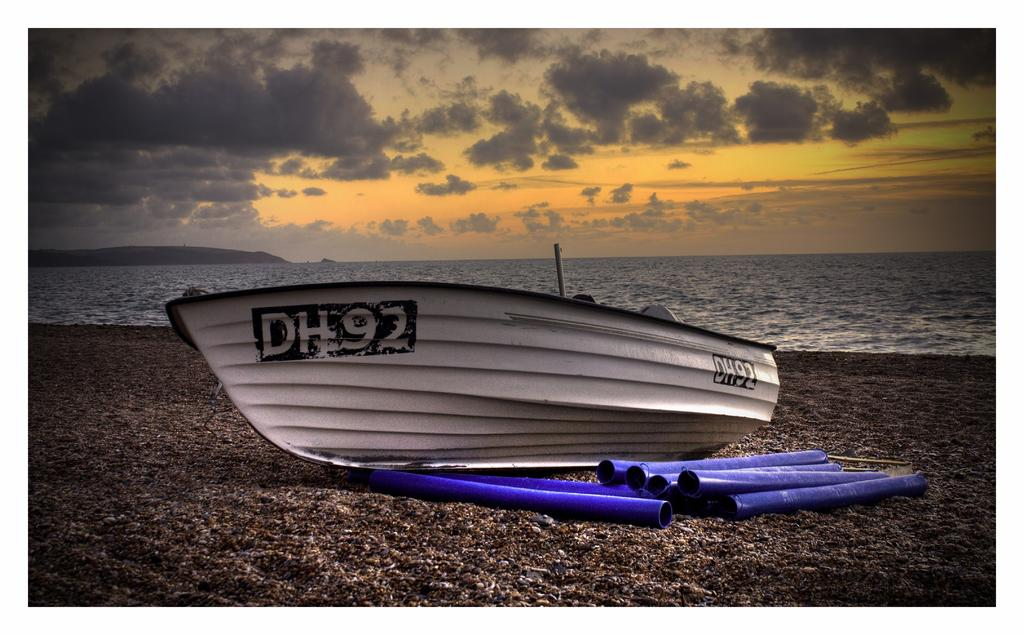What is the main subject of the image? The main subject of the image is a boat. Where is the boat located in the image? The boat is placed on the shore. What can be seen in the background of the image? There is sea, a hill, and the sky visible in the image. What is the condition of the sky in the image? The sky is visible in the image, and there are clouds present. What type of button can be seen on the boat in the image? There is no button present on the boat in the image. Can you tell me how many skateboards are visible in the image? There are no skateboards visible in the image; it features a boat on the shore. Is there a coach present in the image? There is no coach present in the image. 